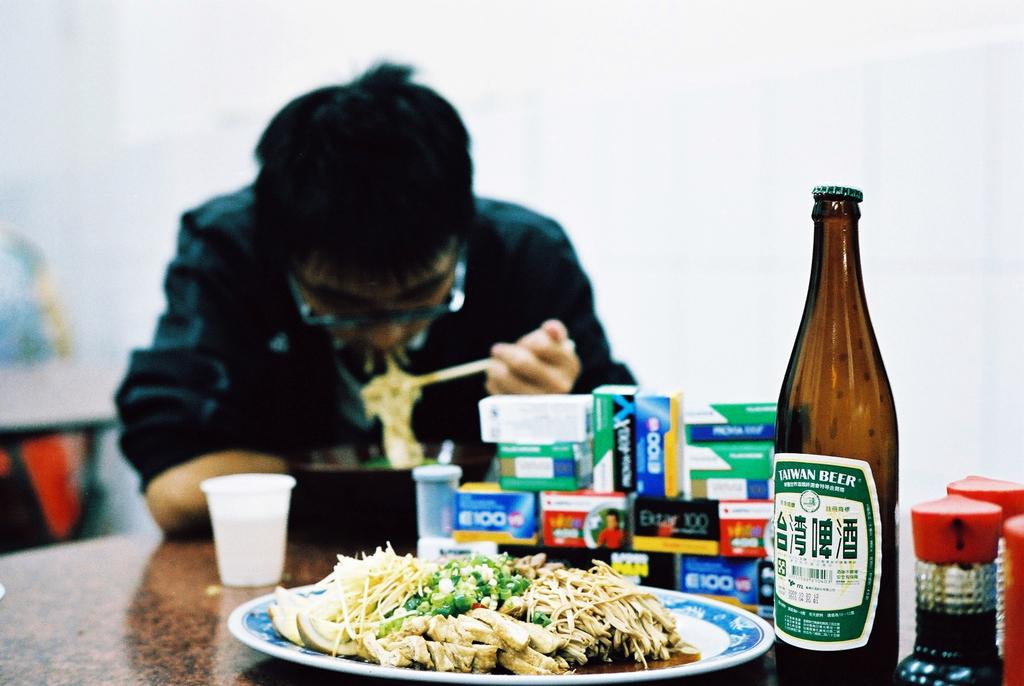<image>
Share a concise interpretation of the image provided. A person is sitting at a table eating noodles with a Taiwan Beer in the foreground. 